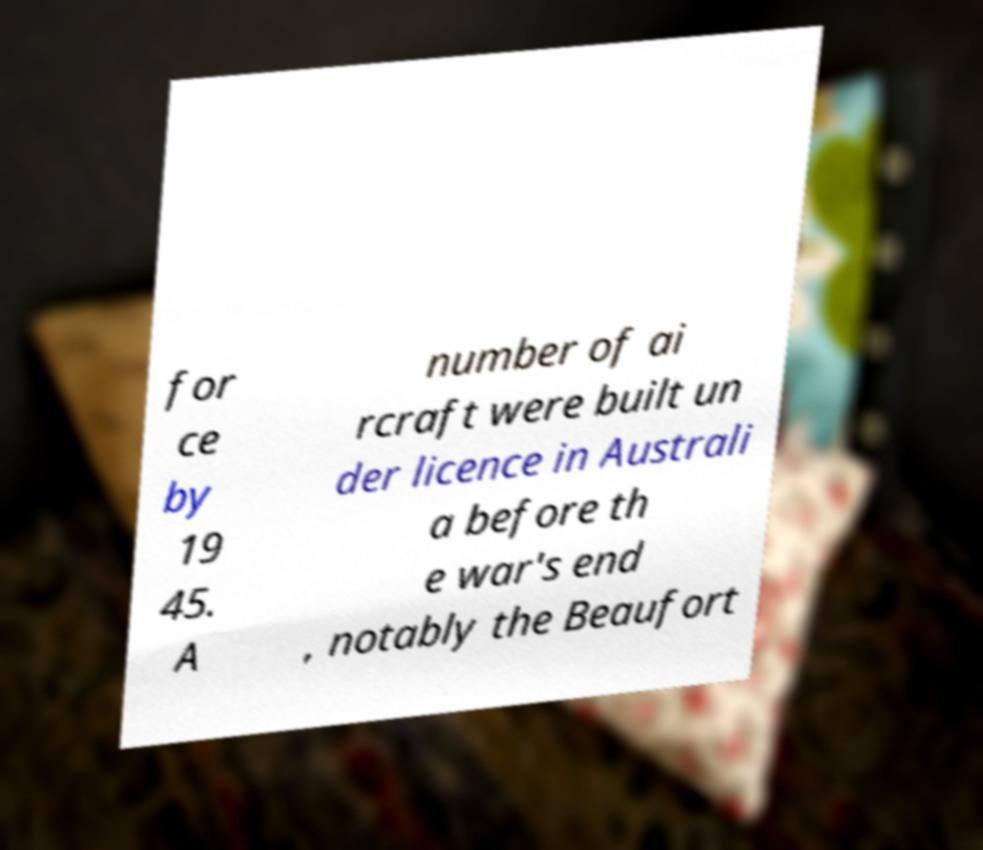Please read and relay the text visible in this image. What does it say? for ce by 19 45. A number of ai rcraft were built un der licence in Australi a before th e war's end , notably the Beaufort 